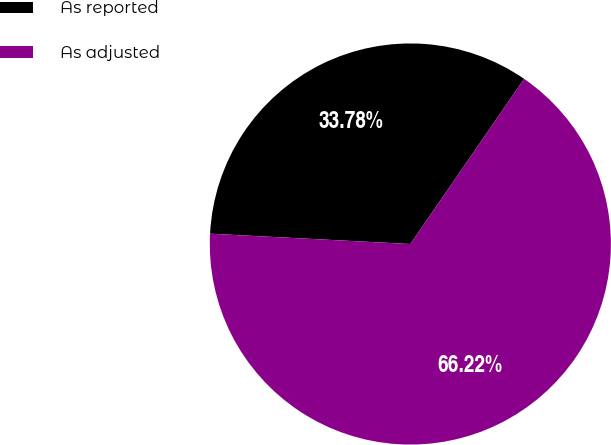<chart> <loc_0><loc_0><loc_500><loc_500><pie_chart><fcel>As reported<fcel>As adjusted<nl><fcel>33.78%<fcel>66.22%<nl></chart> 